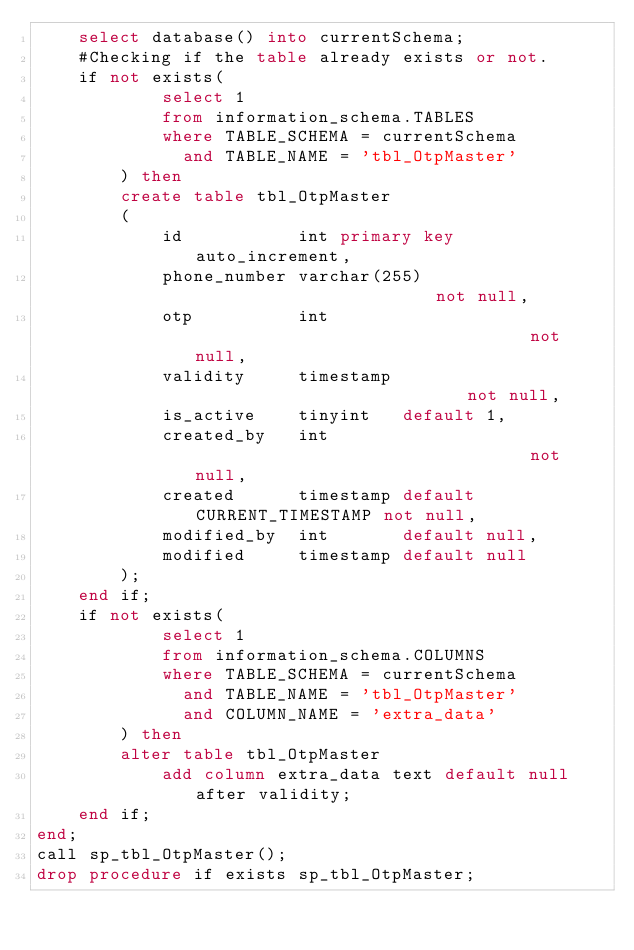Convert code to text. <code><loc_0><loc_0><loc_500><loc_500><_SQL_>    select database() into currentSchema;
    #Checking if the table already exists or not.
    if not exists(
            select 1
            from information_schema.TABLES
            where TABLE_SCHEMA = currentSchema
              and TABLE_NAME = 'tbl_OtpMaster'
        ) then
        create table tbl_OtpMaster
        (
            id           int primary key auto_increment,
            phone_number varchar(255)                        not null,
            otp          int                                 not null,
            validity     timestamp                           not null,
            is_active    tinyint   default 1,
            created_by   int                                 not null,
            created      timestamp default CURRENT_TIMESTAMP not null,
            modified_by  int       default null,
            modified     timestamp default null
        );
    end if;
    if not exists(
            select 1
            from information_schema.COLUMNS
            where TABLE_SCHEMA = currentSchema
              and TABLE_NAME = 'tbl_OtpMaster'
              and COLUMN_NAME = 'extra_data'
        ) then
        alter table tbl_OtpMaster
            add column extra_data text default null after validity;
    end if;
end;
call sp_tbl_OtpMaster();
drop procedure if exists sp_tbl_OtpMaster;</code> 